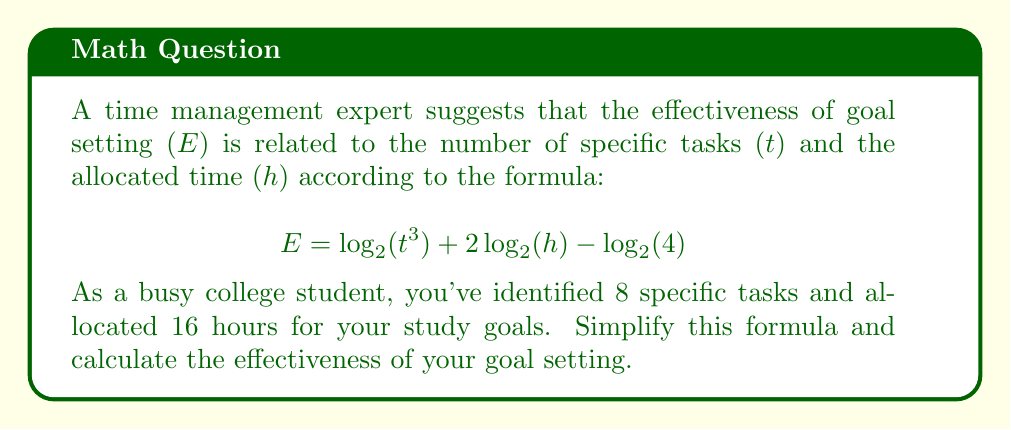Provide a solution to this math problem. Let's simplify the formula step by step using the properties of logarithms:

1) Start with the given formula:
   $$E = \log_2(t^3) + 2\log_2(h) - \log_2(4)$$

2) Apply the power property of logarithms to simplify $\log_2(t^3)$:
   $$E = 3\log_2(t) + 2\log_2(h) - \log_2(4)$$

3) Recognize that $\log_2(4) = 2$ (since $2^2 = 4$):
   $$E = 3\log_2(t) + 2\log_2(h) - 2$$

4) Now, let's substitute the given values: $t = 8$ and $h = 16$
   $$E = 3\log_2(8) + 2\log_2(16) - 2$$

5) Simplify $\log_2(8)$ and $\log_2(16)$:
   $\log_2(8) = 3$ (since $2^3 = 8$)
   $\log_2(16) = 4$ (since $2^4 = 16$)

6) Substitute these values:
   $$E = 3(3) + 2(4) - 2$$

7) Calculate:
   $$E = 9 + 8 - 2 = 15$$

Therefore, the effectiveness of your goal setting is 15.
Answer: 15 